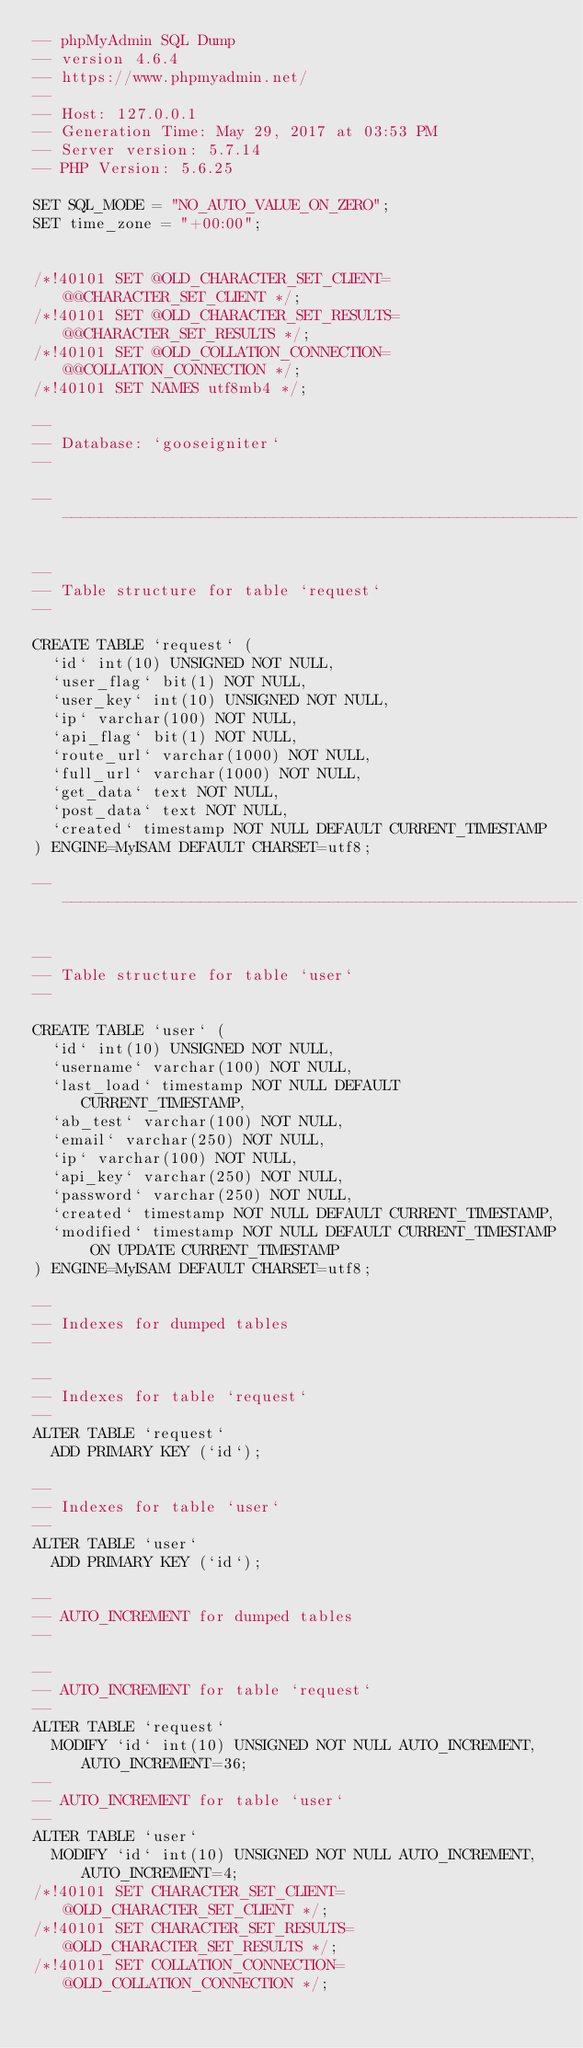Convert code to text. <code><loc_0><loc_0><loc_500><loc_500><_SQL_>-- phpMyAdmin SQL Dump
-- version 4.6.4
-- https://www.phpmyadmin.net/
--
-- Host: 127.0.0.1
-- Generation Time: May 29, 2017 at 03:53 PM
-- Server version: 5.7.14
-- PHP Version: 5.6.25

SET SQL_MODE = "NO_AUTO_VALUE_ON_ZERO";
SET time_zone = "+00:00";


/*!40101 SET @OLD_CHARACTER_SET_CLIENT=@@CHARACTER_SET_CLIENT */;
/*!40101 SET @OLD_CHARACTER_SET_RESULTS=@@CHARACTER_SET_RESULTS */;
/*!40101 SET @OLD_COLLATION_CONNECTION=@@COLLATION_CONNECTION */;
/*!40101 SET NAMES utf8mb4 */;

--
-- Database: `gooseigniter`
--

-- --------------------------------------------------------

--
-- Table structure for table `request`
--

CREATE TABLE `request` (
  `id` int(10) UNSIGNED NOT NULL,
  `user_flag` bit(1) NOT NULL,
  `user_key` int(10) UNSIGNED NOT NULL,
  `ip` varchar(100) NOT NULL,
  `api_flag` bit(1) NOT NULL,
  `route_url` varchar(1000) NOT NULL,
  `full_url` varchar(1000) NOT NULL,
  `get_data` text NOT NULL,
  `post_data` text NOT NULL,
  `created` timestamp NOT NULL DEFAULT CURRENT_TIMESTAMP
) ENGINE=MyISAM DEFAULT CHARSET=utf8;

-- --------------------------------------------------------

--
-- Table structure for table `user`
--

CREATE TABLE `user` (
  `id` int(10) UNSIGNED NOT NULL,
  `username` varchar(100) NOT NULL,
  `last_load` timestamp NOT NULL DEFAULT CURRENT_TIMESTAMP,
  `ab_test` varchar(100) NOT NULL,
  `email` varchar(250) NOT NULL,
  `ip` varchar(100) NOT NULL,
  `api_key` varchar(250) NOT NULL,
  `password` varchar(250) NOT NULL,
  `created` timestamp NOT NULL DEFAULT CURRENT_TIMESTAMP,
  `modified` timestamp NOT NULL DEFAULT CURRENT_TIMESTAMP ON UPDATE CURRENT_TIMESTAMP
) ENGINE=MyISAM DEFAULT CHARSET=utf8;

--
-- Indexes for dumped tables
--

--
-- Indexes for table `request`
--
ALTER TABLE `request`
  ADD PRIMARY KEY (`id`);

--
-- Indexes for table `user`
--
ALTER TABLE `user`
  ADD PRIMARY KEY (`id`);

--
-- AUTO_INCREMENT for dumped tables
--

--
-- AUTO_INCREMENT for table `request`
--
ALTER TABLE `request`
  MODIFY `id` int(10) UNSIGNED NOT NULL AUTO_INCREMENT, AUTO_INCREMENT=36;
--
-- AUTO_INCREMENT for table `user`
--
ALTER TABLE `user`
  MODIFY `id` int(10) UNSIGNED NOT NULL AUTO_INCREMENT, AUTO_INCREMENT=4;
/*!40101 SET CHARACTER_SET_CLIENT=@OLD_CHARACTER_SET_CLIENT */;
/*!40101 SET CHARACTER_SET_RESULTS=@OLD_CHARACTER_SET_RESULTS */;
/*!40101 SET COLLATION_CONNECTION=@OLD_COLLATION_CONNECTION */;
</code> 